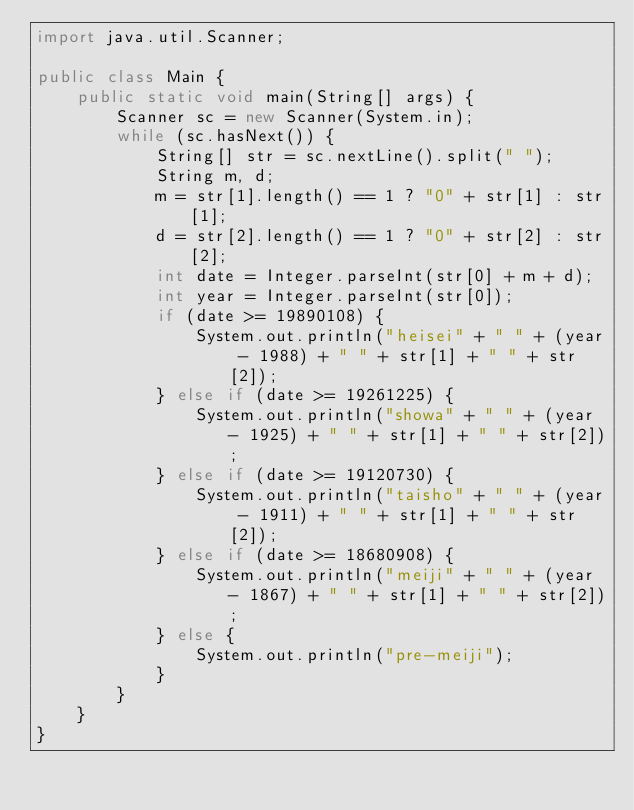Convert code to text. <code><loc_0><loc_0><loc_500><loc_500><_Java_>import java.util.Scanner;

public class Main {
    public static void main(String[] args) {
        Scanner sc = new Scanner(System.in);
        while (sc.hasNext()) {
            String[] str = sc.nextLine().split(" ");
            String m, d;
            m = str[1].length() == 1 ? "0" + str[1] : str[1];
            d = str[2].length() == 1 ? "0" + str[2] : str[2];
            int date = Integer.parseInt(str[0] + m + d);
            int year = Integer.parseInt(str[0]);
            if (date >= 19890108) {
                System.out.println("heisei" + " " + (year - 1988) + " " + str[1] + " " + str[2]);
            } else if (date >= 19261225) {
                System.out.println("showa" + " " + (year - 1925) + " " + str[1] + " " + str[2]);
            } else if (date >= 19120730) {
                System.out.println("taisho" + " " + (year - 1911) + " " + str[1] + " " + str[2]);
            } else if (date >= 18680908) {
                System.out.println("meiji" + " " + (year - 1867) + " " + str[1] + " " + str[2]);
            } else {
                System.out.println("pre-meiji");
            }
        }
    }
}</code> 